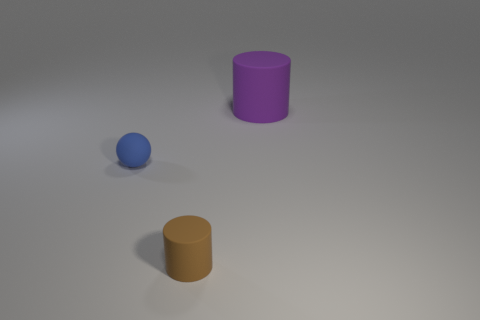What number of matte objects are both on the right side of the tiny matte cylinder and in front of the large thing?
Your answer should be compact. 0. What is the material of the cylinder that is to the left of the cylinder to the right of the tiny matte cylinder?
Give a very brief answer. Rubber. Is there a big purple object that has the same material as the large cylinder?
Offer a terse response. No. There is a brown thing that is the same size as the sphere; what material is it?
Your response must be concise. Rubber. What size is the object that is right of the cylinder that is on the left side of the rubber cylinder that is right of the small brown thing?
Give a very brief answer. Large. There is a object that is in front of the tiny sphere; is there a small sphere that is in front of it?
Your answer should be very brief. No. There is a blue matte thing; does it have the same shape as the thing that is right of the small rubber cylinder?
Provide a short and direct response. No. What color is the rubber thing left of the brown matte object?
Make the answer very short. Blue. There is a object right of the rubber cylinder left of the purple object; what is its size?
Offer a very short reply. Large. Do the object behind the blue rubber sphere and the small blue matte object have the same shape?
Make the answer very short. No. 